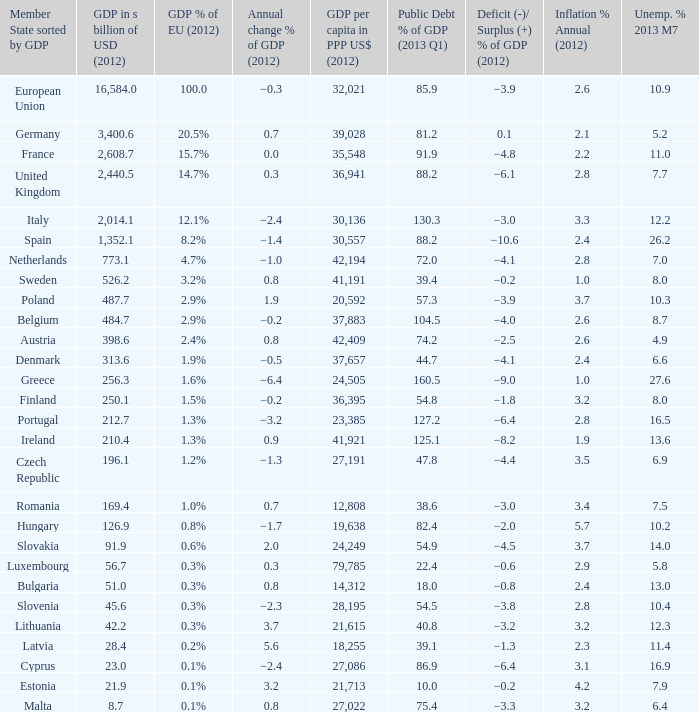9%? 2.6. 